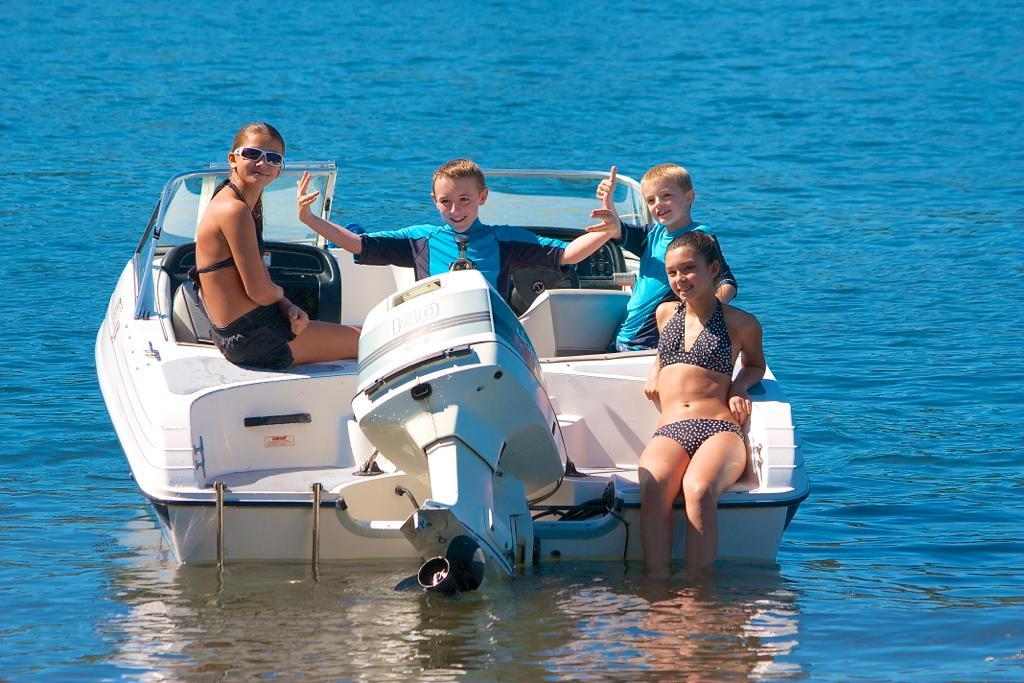How would you summarize this image in a sentence or two? In this picture I can see few people seated in the boat and I can see a girl seated and I can see her legs in the water and a girl wore sunglasses. 